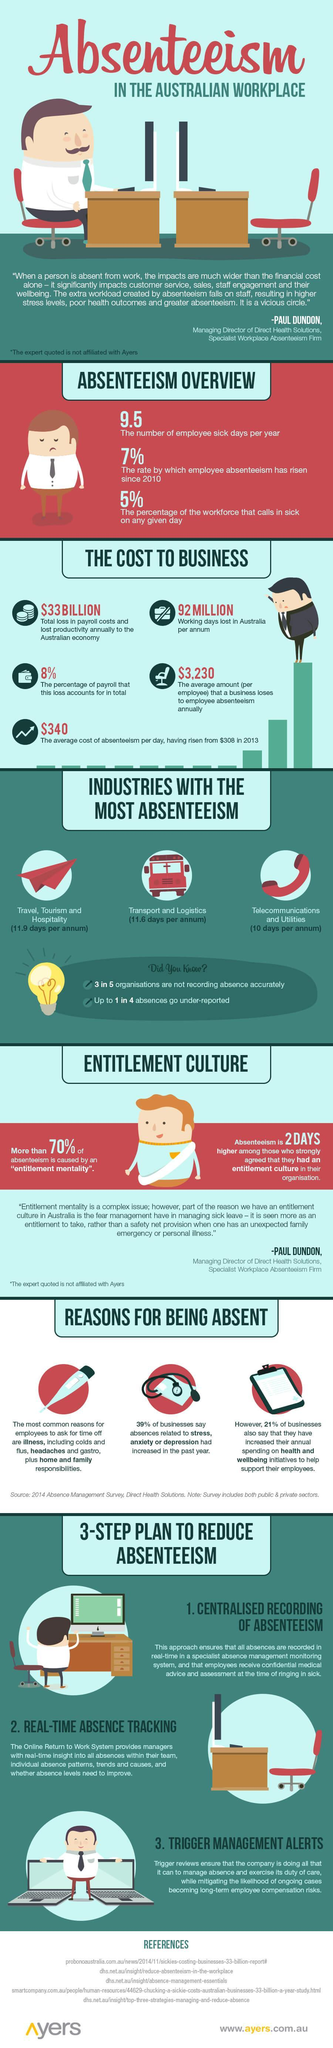Which industry encountered the lowest absenteeism in the australian workplace?
Answer the question with a short phrase. Telecommunications and Utilities What is the second step in the plan to reduce absenteeism? Real-Time Absence Tracking What percent of businesses has increased their annual spending on health & wellbeing of the employees? 21% What is the average amount that a business loses to employee absenteeism annually? $3,230 Which industry encountered the highest absenteeism in the australian workplace? Travel, Tourism and Hospitality What is the total working days lost in Australia per annum as part of absenteeism? 92 MILLION 